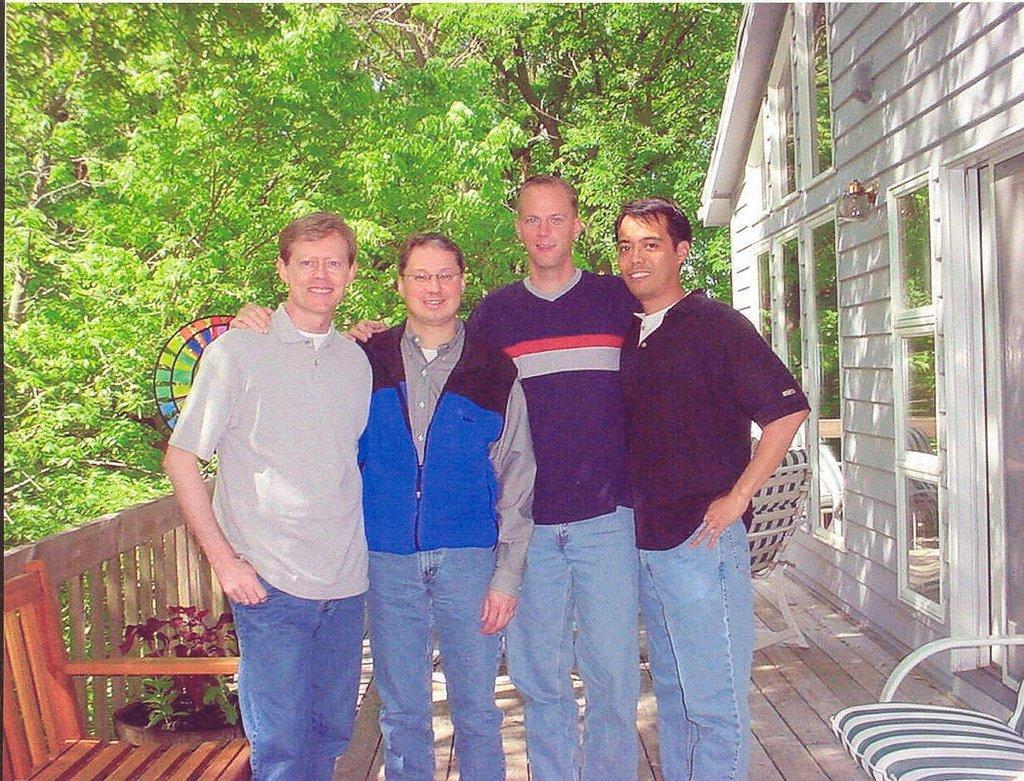Can you describe this image briefly? In the given image I can see a people, fence, chairs, house, plant and in the background I can see the trees. 